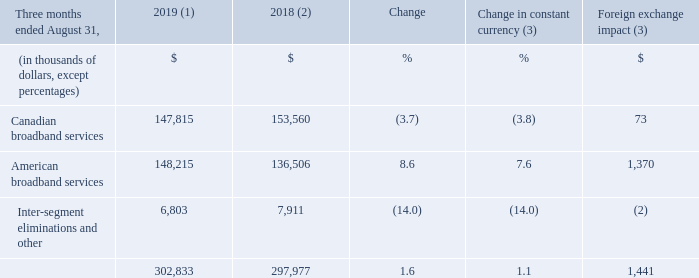OPERATING EXPENSES
(1) For the three-month period ended August 31, 2019, the average foreign exchange rate used for translation was 1.3222 USD/CDN.
(2) Fiscal 2018 was restated to comply with IFRS 15 and to reflect a change in accounting policy as well as to reclassify results from Cogeco Peer 1 as discontinued operations. For further details, please consult the "Accounting policies" and "Discontinued operations" sections.
(3) Fiscal 2019 actuals are translated at the average foreign exchange rate of the comparable period of fiscal 2018 which was 1.3100 USD/CDN.
Fiscal 2019 fourth-quarter operating expenses increased by 1.6% (1.1% in constant currency) mainly from: • additional costs in the American broadband services segment mainly due to higher programming costs, additional headcount to support growth, higher marketing initiatives to drive primary service units growth and the FiberLight acquisition;
What was the exchange rate for the three-month period ended August 31, 2019? 1.3222 usd/cdn. What was the exchange rate for the three-month period ended august 2018? 1.3100 usd/cdn. What was the increase in the operating expenses in 2019 fourth-quarter fiscal year? 1.6%. What was the increase / (decrease) in the Canadian broadband services from three months ended August 31, 2018 to 2019?
Answer scale should be: thousand. 147,815 - 153,560
Answer: -5745. What was the average American broadband services from three months ended August 31, 2018 to 2019?
Answer scale should be: thousand. (148,215 + 136,506) / 2
Answer: 142360.5. What was the increase / (decrease) in the Inter-segment eliminations and other from three months ended August 31, 2018 to 2019?
Answer scale should be: thousand. 6,803 - 7,911
Answer: -1108. 